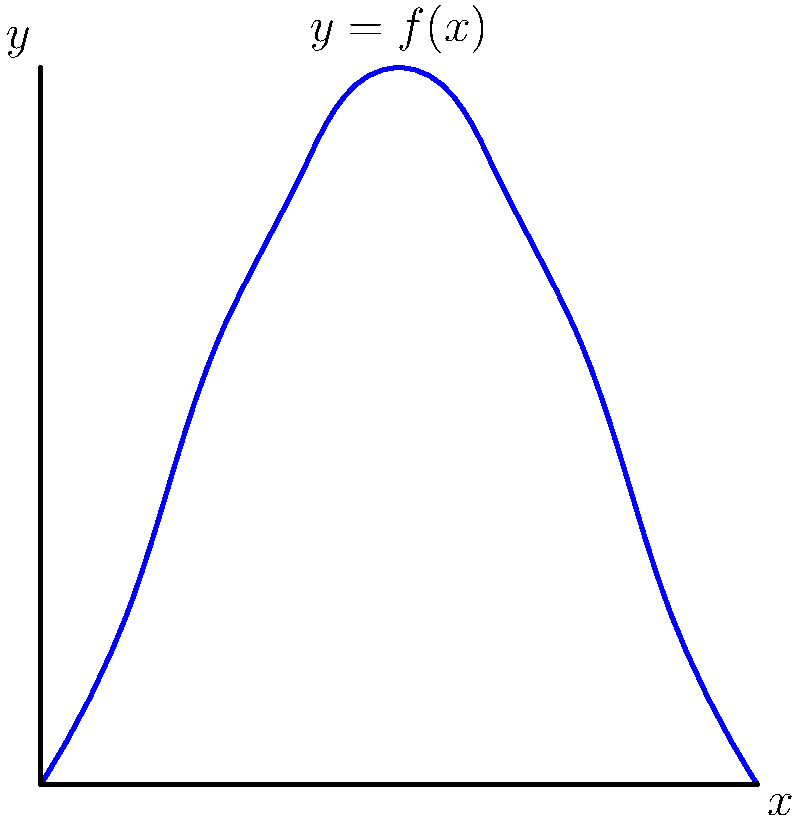A renowned French winemaker has designed a unique wine bottle inspired by the Eiffel Tower. The silhouette of the bottle is represented by the function $y = f(x)$ in centimeters, where $x$ is the distance from the base and $y$ is the radius at that point. If the bottle is 8 cm tall, calculate its volume in cubic centimeters using the method of disc integration. To solve this problem, we'll use the disc method of integration:

1) The volume of a solid of revolution is given by:
   $$V = \pi \int_a^b [f(x)]^2 dx$$

2) In this case, $a = 0$ and $b = 8$ (the height of the bottle in cm).

3) We don't have an explicit function for $f(x)$, but we can express the volume as:
   $$V = \pi \int_0^8 [f(x)]^2 dx$$

4) This integral represents the sum of the volumes of infinitesimally thin discs stacked from the base to the top of the bottle.

5) Without a specific function, we can't evaluate this integral analytically. In practice, numerical methods like the trapezoidal rule or Simpson's rule would be used to approximate the integral.

6) The result would be in cubic centimeters (cm³) as we're integrating over centimeters and squaring the radius (also in cm).

Note: In a real-world scenario, the winemaker would need to provide more specific data about the bottle's shape to calculate an exact volume.
Answer: $V = \pi \int_0^8 [f(x)]^2 dx$ cm³ 